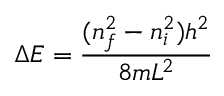<formula> <loc_0><loc_0><loc_500><loc_500>\Delta E = { \frac { ( n _ { f } ^ { 2 } - n _ { i } ^ { 2 } ) h ^ { 2 } } { 8 m L ^ { 2 } } }</formula> 